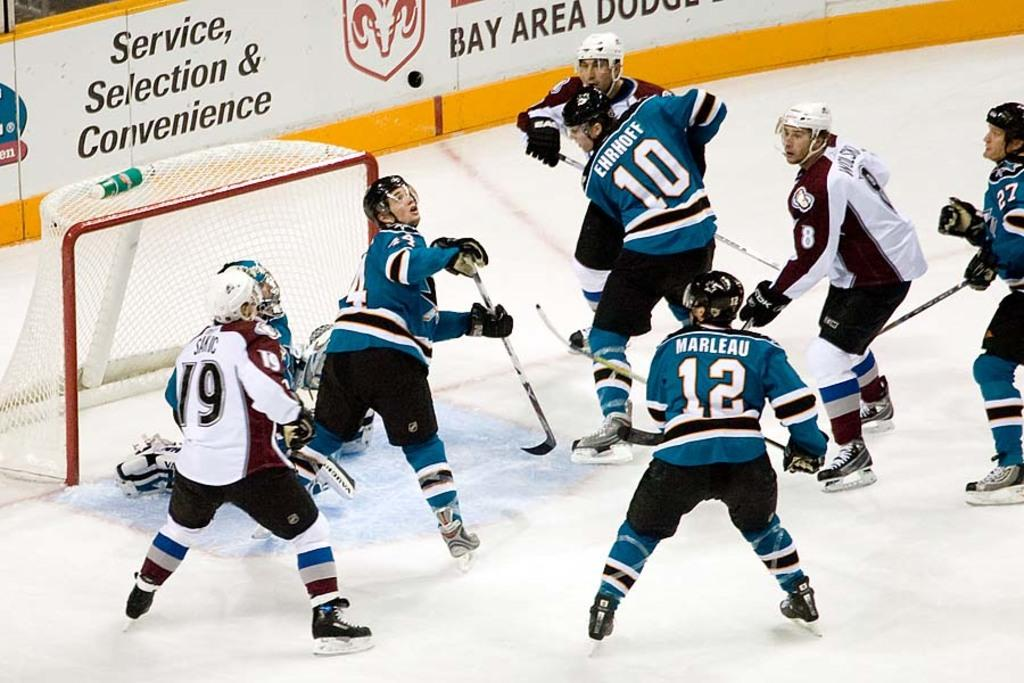<image>
Give a short and clear explanation of the subsequent image. The player who is number 12 is named Marleau. 